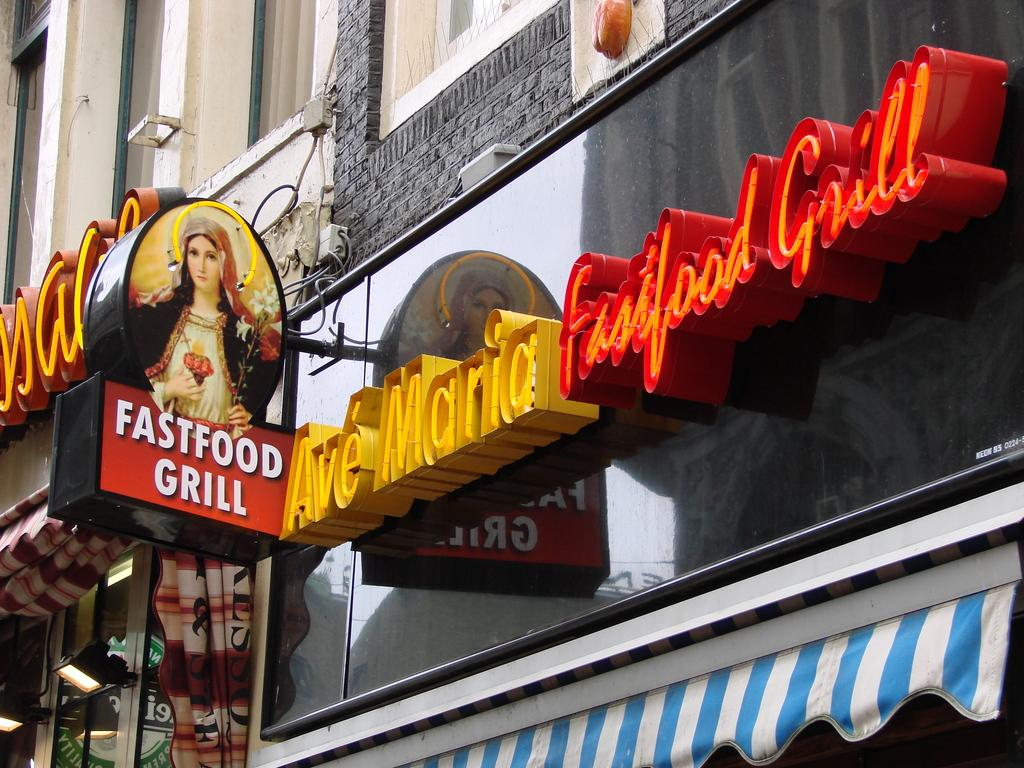How many buildings can be seen in the image? There are two buildings in the image. What feature do the buildings have? The buildings have lights. What other objects are present in the image? There are light boards and a board with a photo of a person in the image. Is there any text visible in the image? Yes, there is a name board in the image. How does the authority figure fall from the sky in the image? There is no authority figure falling from the sky in the image; it only features two buildings, light boards, a board with a photo of a person, and a name board. Is there any rain visible in the image? No, there is no rain present in the image. 